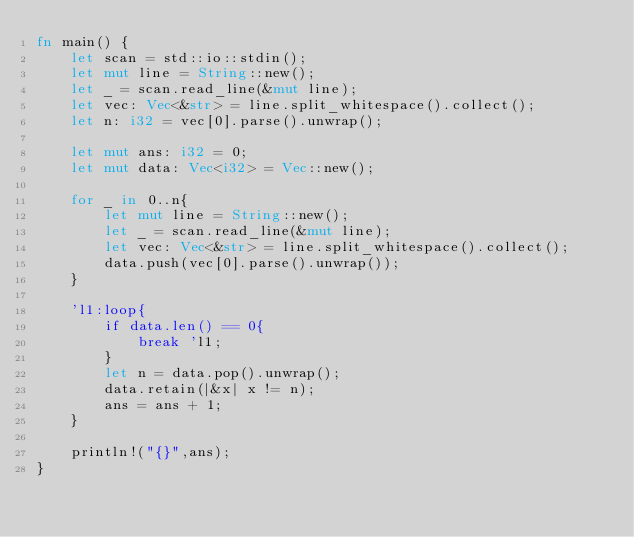<code> <loc_0><loc_0><loc_500><loc_500><_Rust_>fn main() {
    let scan = std::io::stdin();
    let mut line = String::new();
    let _ = scan.read_line(&mut line);
    let vec: Vec<&str> = line.split_whitespace().collect();
    let n: i32 = vec[0].parse().unwrap();

    let mut ans: i32 = 0;
    let mut data: Vec<i32> = Vec::new();

    for _ in 0..n{
        let mut line = String::new();
        let _ = scan.read_line(&mut line);
        let vec: Vec<&str> = line.split_whitespace().collect();
        data.push(vec[0].parse().unwrap());
    }

    'l1:loop{
        if data.len() == 0{
            break 'l1;
        }
        let n = data.pop().unwrap();
        data.retain(|&x| x != n);
        ans = ans + 1;
    }

    println!("{}",ans);
}
</code> 